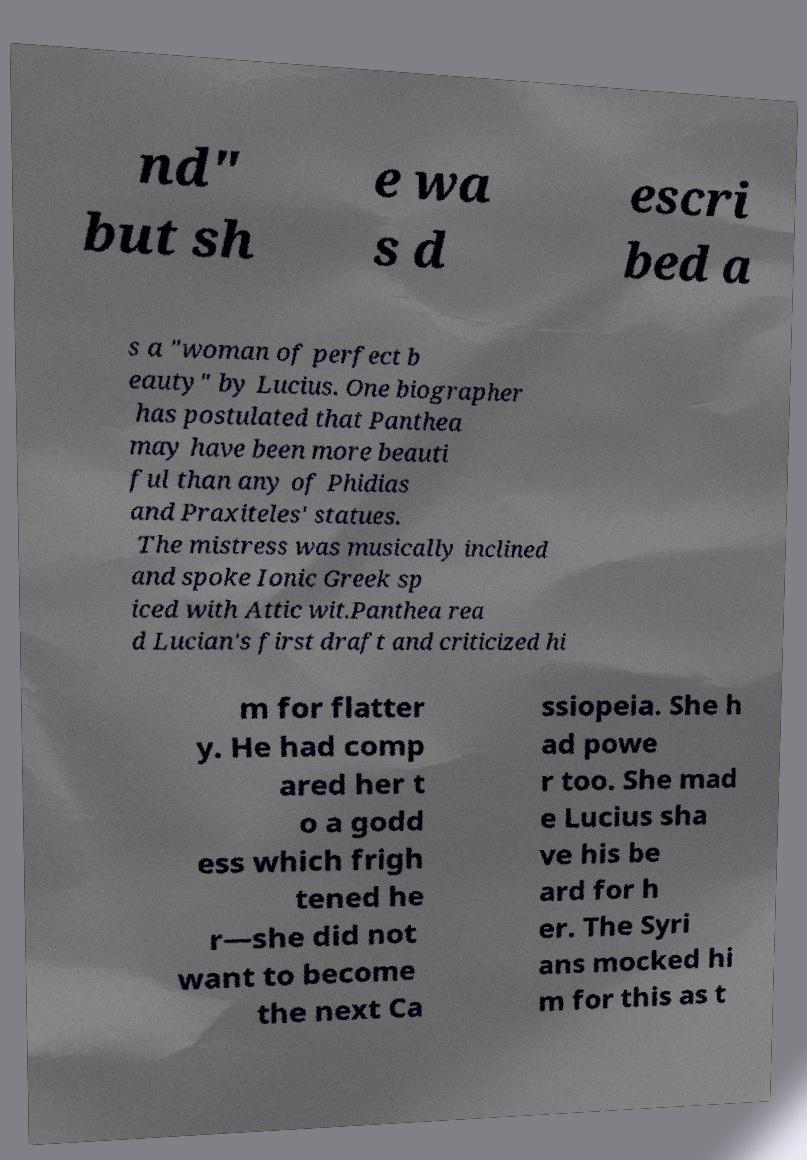Could you extract and type out the text from this image? nd" but sh e wa s d escri bed a s a "woman of perfect b eauty" by Lucius. One biographer has postulated that Panthea may have been more beauti ful than any of Phidias and Praxiteles' statues. The mistress was musically inclined and spoke Ionic Greek sp iced with Attic wit.Panthea rea d Lucian's first draft and criticized hi m for flatter y. He had comp ared her t o a godd ess which frigh tened he r—she did not want to become the next Ca ssiopeia. She h ad powe r too. She mad e Lucius sha ve his be ard for h er. The Syri ans mocked hi m for this as t 